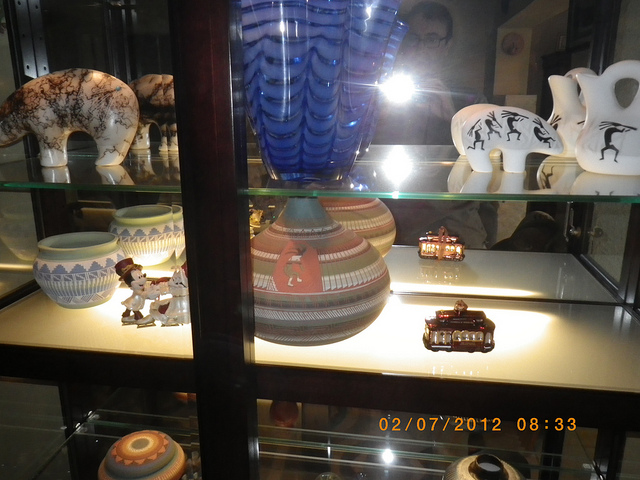Identify and read out the text in this image. 02 07 2012 08 33 